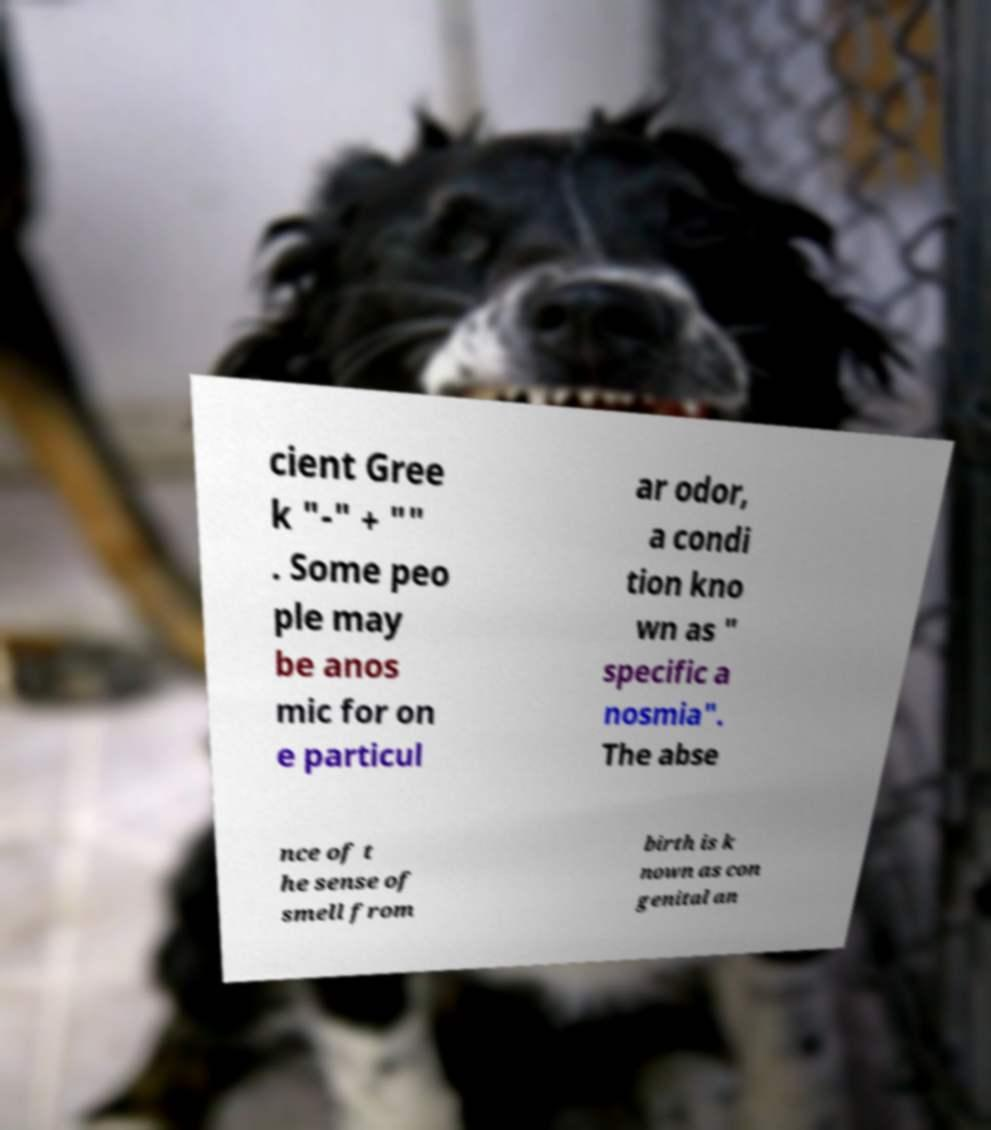What messages or text are displayed in this image? I need them in a readable, typed format. cient Gree k "-" + "" . Some peo ple may be anos mic for on e particul ar odor, a condi tion kno wn as " specific a nosmia". The abse nce of t he sense of smell from birth is k nown as con genital an 